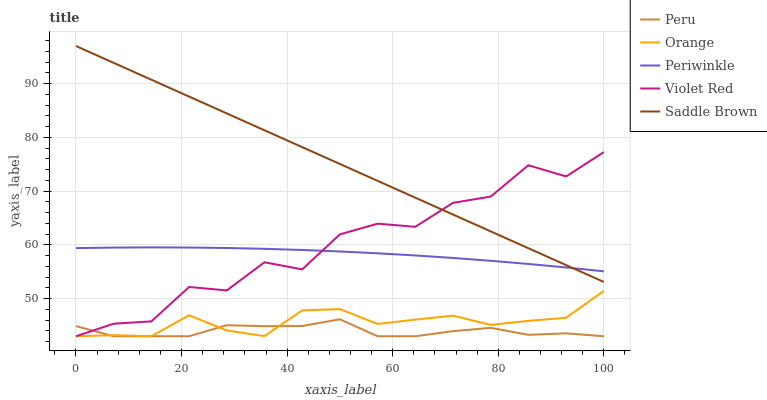Does Peru have the minimum area under the curve?
Answer yes or no. Yes. Does Saddle Brown have the maximum area under the curve?
Answer yes or no. Yes. Does Violet Red have the minimum area under the curve?
Answer yes or no. No. Does Violet Red have the maximum area under the curve?
Answer yes or no. No. Is Saddle Brown the smoothest?
Answer yes or no. Yes. Is Violet Red the roughest?
Answer yes or no. Yes. Is Periwinkle the smoothest?
Answer yes or no. No. Is Periwinkle the roughest?
Answer yes or no. No. Does Orange have the lowest value?
Answer yes or no. Yes. Does Periwinkle have the lowest value?
Answer yes or no. No. Does Saddle Brown have the highest value?
Answer yes or no. Yes. Does Violet Red have the highest value?
Answer yes or no. No. Is Orange less than Periwinkle?
Answer yes or no. Yes. Is Periwinkle greater than Orange?
Answer yes or no. Yes. Does Saddle Brown intersect Periwinkle?
Answer yes or no. Yes. Is Saddle Brown less than Periwinkle?
Answer yes or no. No. Is Saddle Brown greater than Periwinkle?
Answer yes or no. No. Does Orange intersect Periwinkle?
Answer yes or no. No. 